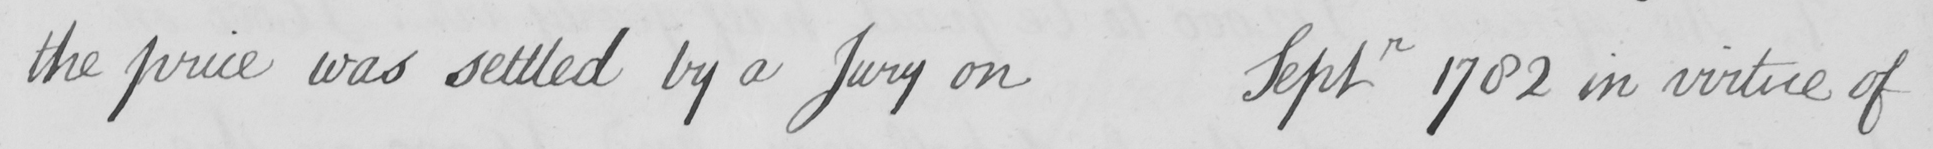Please provide the text content of this handwritten line. the price was settled by a Jury on Septr 1782 in virtue of 